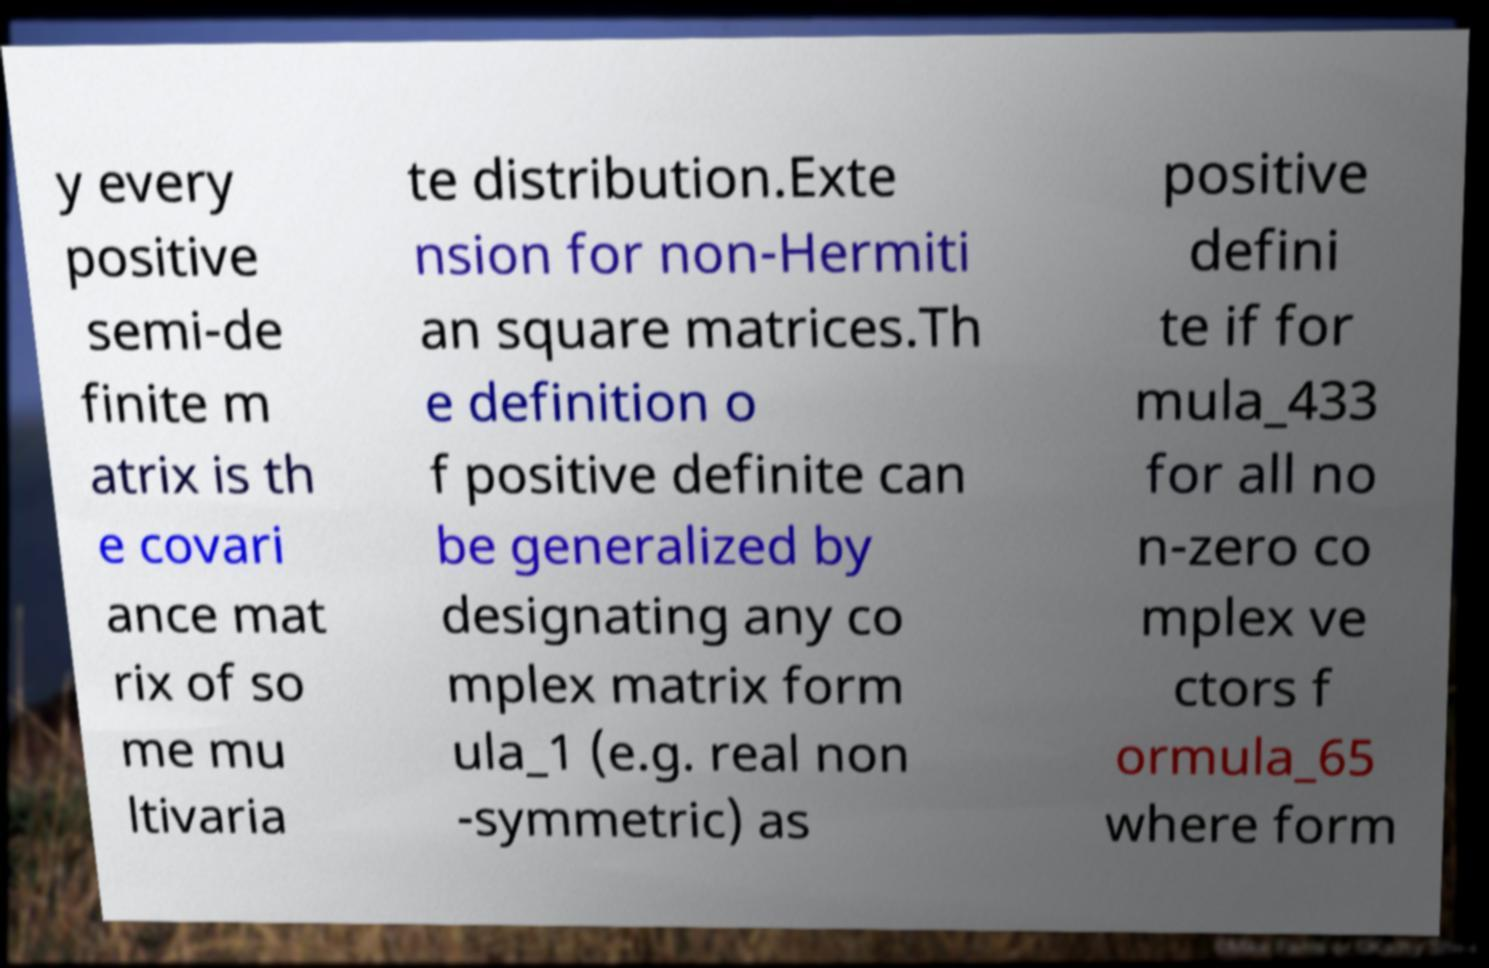For documentation purposes, I need the text within this image transcribed. Could you provide that? y every positive semi-de finite m atrix is th e covari ance mat rix of so me mu ltivaria te distribution.Exte nsion for non-Hermiti an square matrices.Th e definition o f positive definite can be generalized by designating any co mplex matrix form ula_1 (e.g. real non -symmetric) as positive defini te if for mula_433 for all no n-zero co mplex ve ctors f ormula_65 where form 